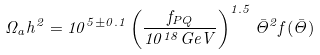<formula> <loc_0><loc_0><loc_500><loc_500>\Omega _ { a } h ^ { 2 } = 1 0 ^ { 5 \pm 0 . 1 } \left ( \frac { f _ { P Q } } { 1 0 ^ { 1 8 } G e V } \right ) ^ { 1 . 5 } \bar { \Theta } ^ { 2 } f ( \bar { \Theta } )</formula> 